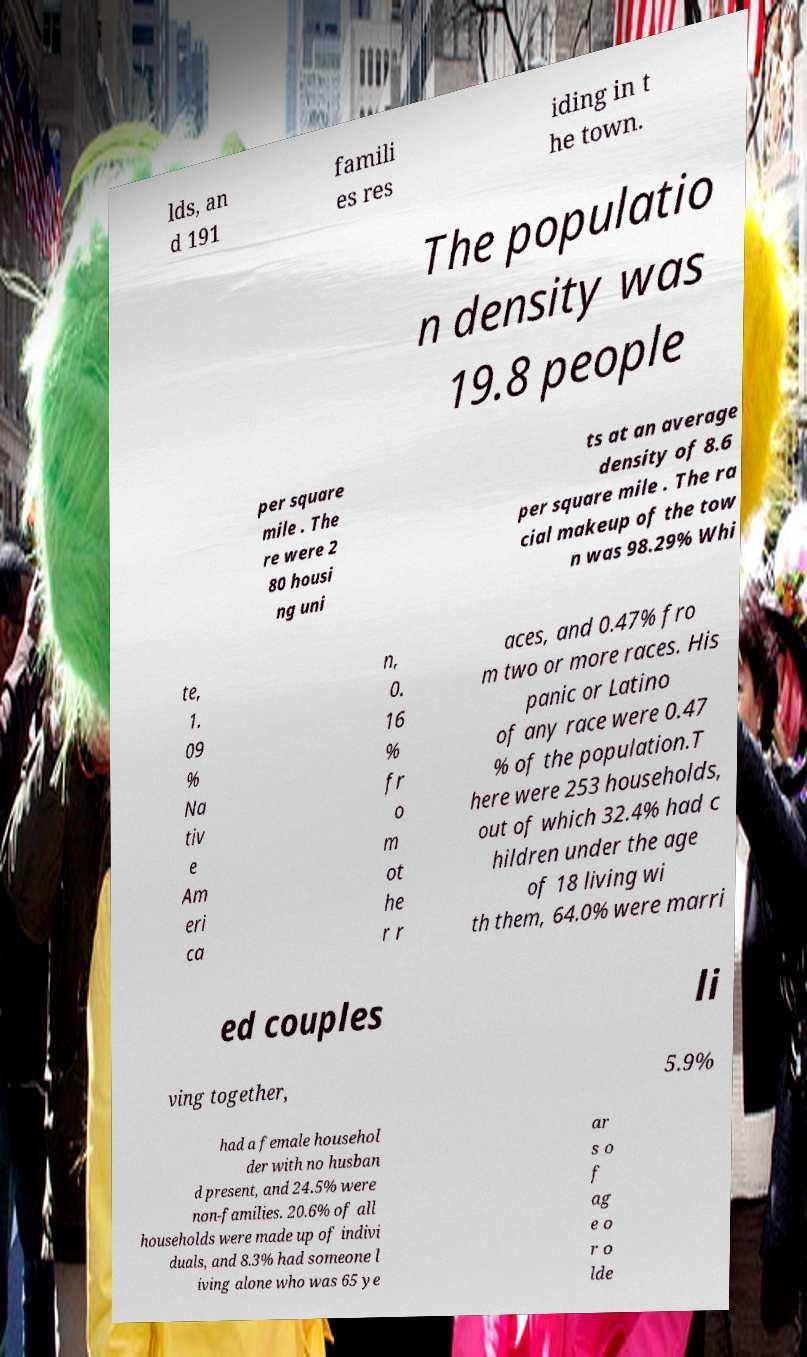Could you assist in decoding the text presented in this image and type it out clearly? lds, an d 191 famili es res iding in t he town. The populatio n density was 19.8 people per square mile . The re were 2 80 housi ng uni ts at an average density of 8.6 per square mile . The ra cial makeup of the tow n was 98.29% Whi te, 1. 09 % Na tiv e Am eri ca n, 0. 16 % fr o m ot he r r aces, and 0.47% fro m two or more races. His panic or Latino of any race were 0.47 % of the population.T here were 253 households, out of which 32.4% had c hildren under the age of 18 living wi th them, 64.0% were marri ed couples li ving together, 5.9% had a female househol der with no husban d present, and 24.5% were non-families. 20.6% of all households were made up of indivi duals, and 8.3% had someone l iving alone who was 65 ye ar s o f ag e o r o lde 